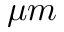Convert formula to latex. <formula><loc_0><loc_0><loc_500><loc_500>\mu m</formula> 